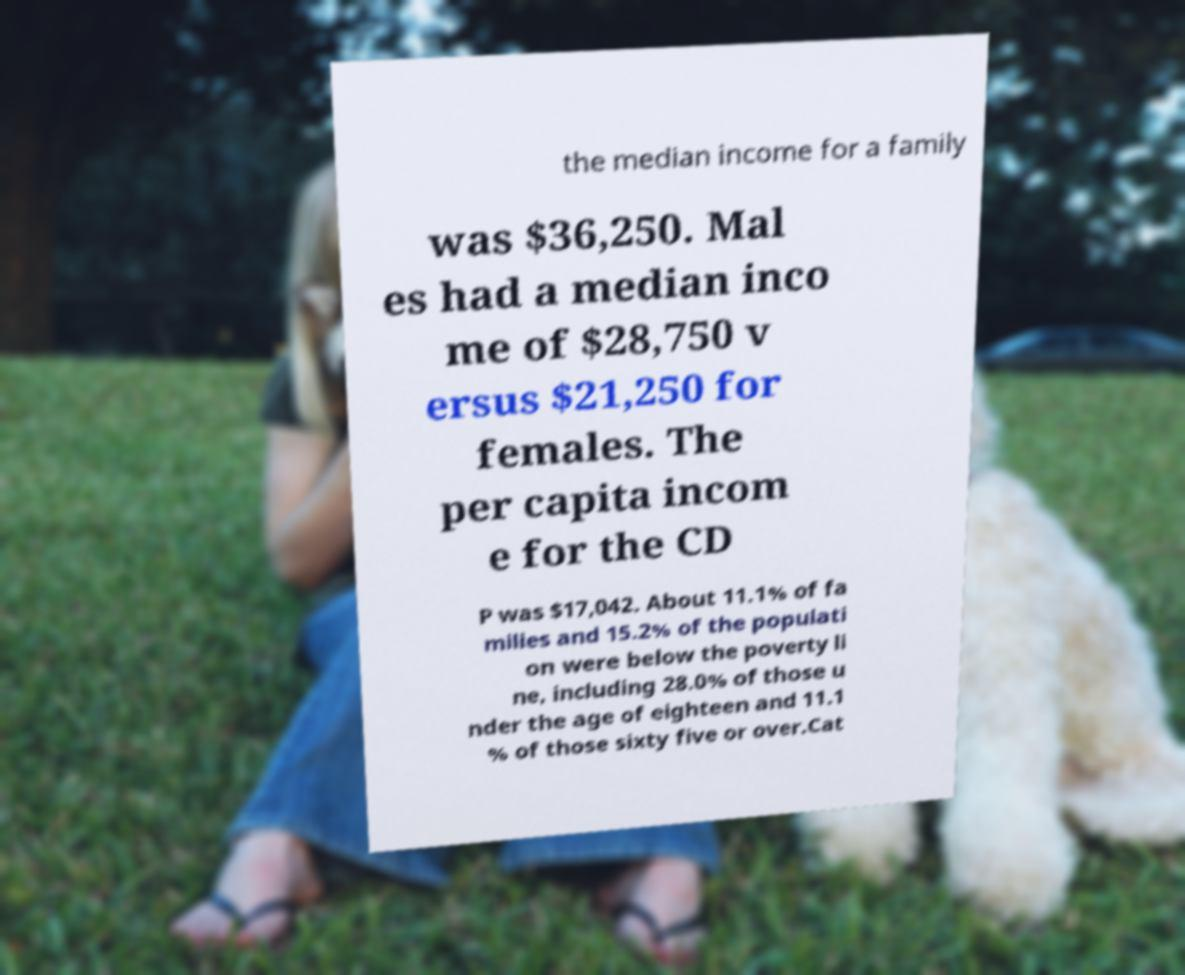Could you assist in decoding the text presented in this image and type it out clearly? the median income for a family was $36,250. Mal es had a median inco me of $28,750 v ersus $21,250 for females. The per capita incom e for the CD P was $17,042. About 11.1% of fa milies and 15.2% of the populati on were below the poverty li ne, including 28.0% of those u nder the age of eighteen and 11.1 % of those sixty five or over.Cat 